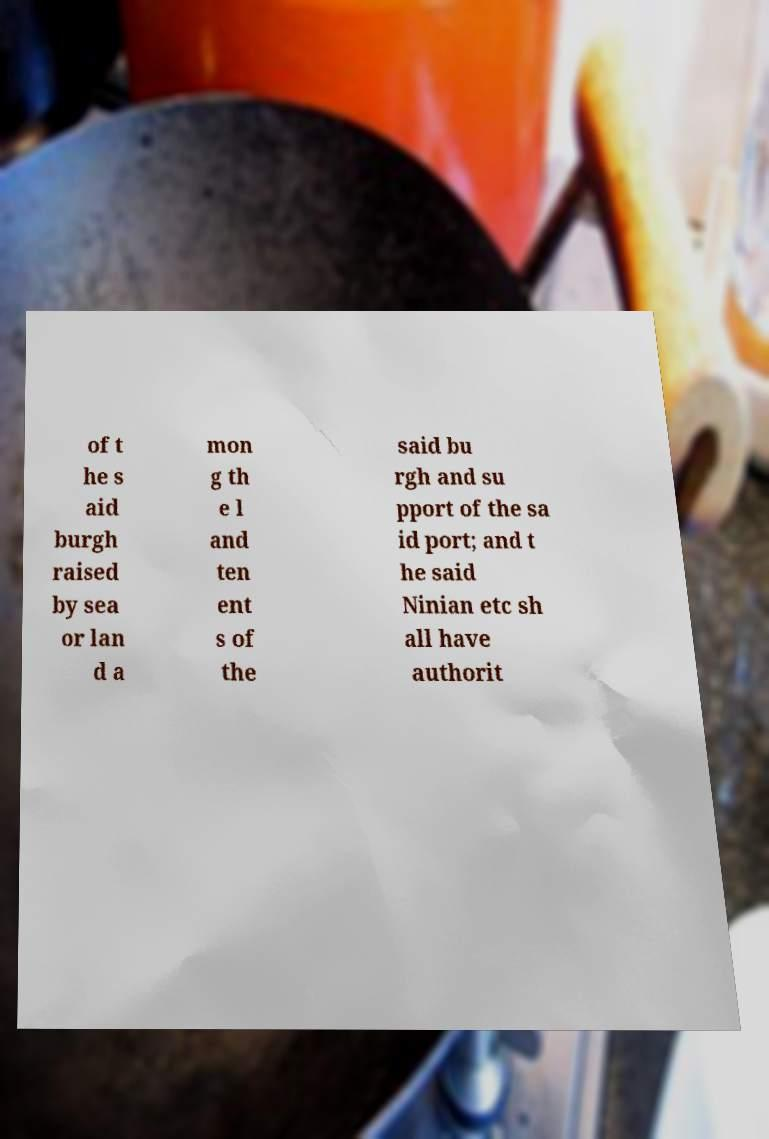What messages or text are displayed in this image? I need them in a readable, typed format. of t he s aid burgh raised by sea or lan d a mon g th e l and ten ent s of the said bu rgh and su pport of the sa id port; and t he said Ninian etc sh all have authorit 